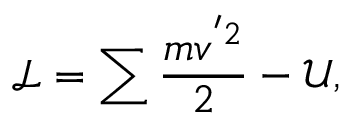Convert formula to latex. <formula><loc_0><loc_0><loc_500><loc_500>\mathcal { L } = \sum \frac { m v ^ { ^ { \prime } 2 } } { 2 } - \mathcal { U } ,</formula> 